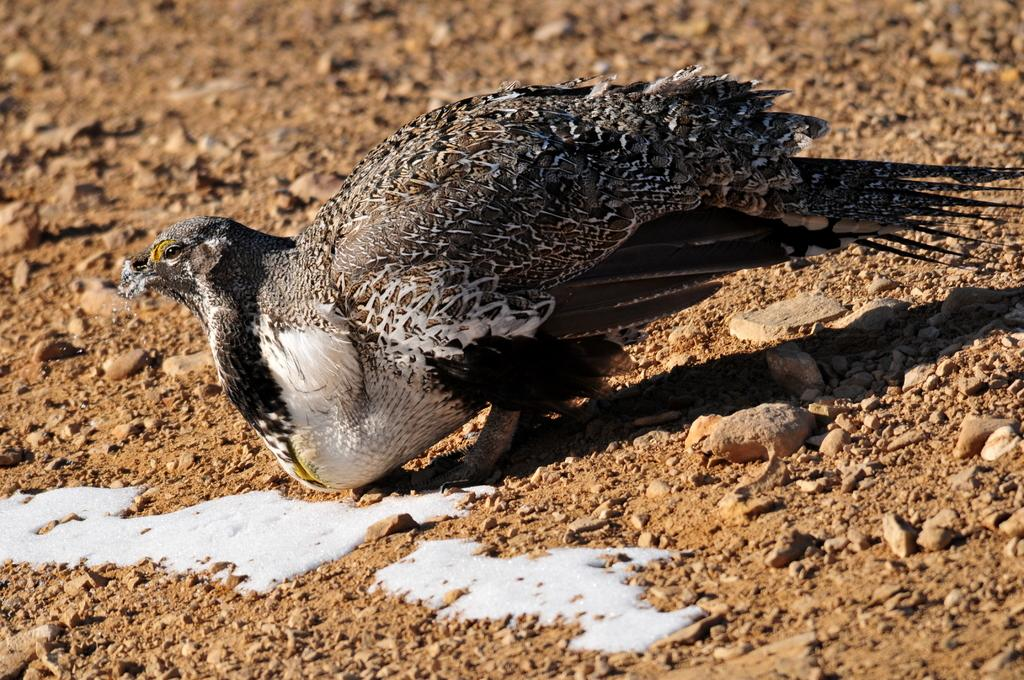What type of animal is present in the image? There is a bird in the image in the image. What can be seen on the ground in the image? There are small stones and a white-colored liquid on the ground in the image. How does the bird measure the wind in the image? The bird does not measure the wind in the image; there is no indication of wind or any measuring device. 